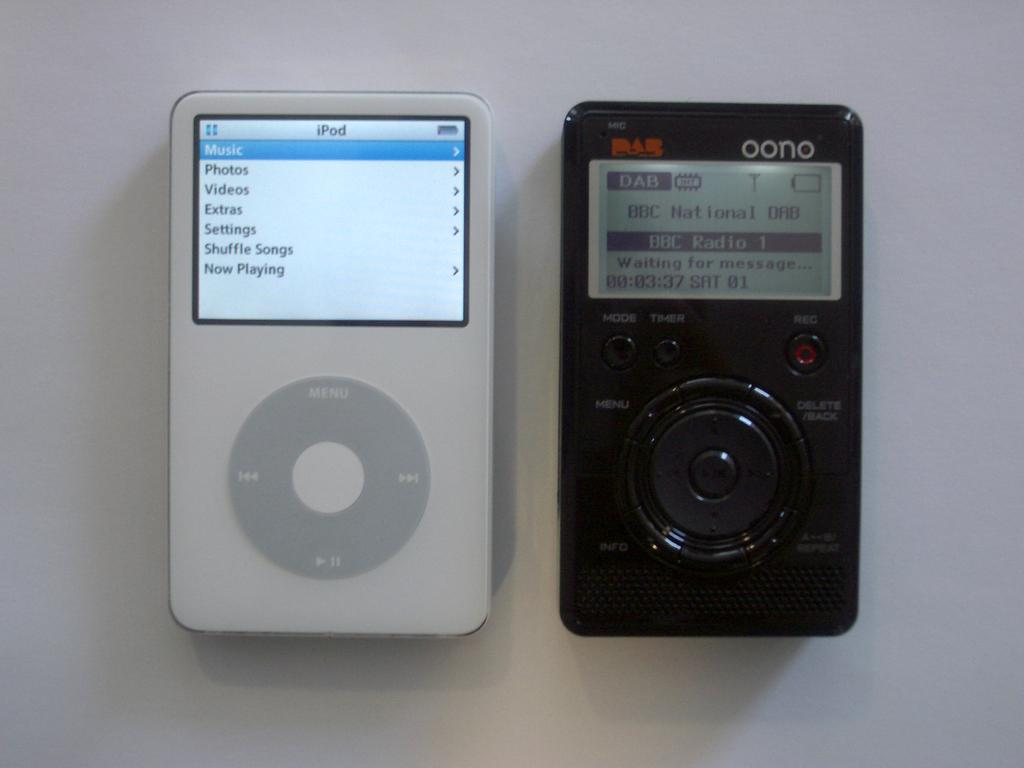What type of device is shown in the image? There are two airpods in the image. What colors are the airpods? The airpods are black and white in color. What surface are the airpods placed on? The airpods are on a white surface. What features can be seen on the airpods? The airpods have screens and buttons visible on them. What type of plot can be seen in the image? There is no plot visible in the image; it features two airpods on a white surface. Can you see a hole in the airpods in the image? There are no holes visible on the airpods in the image. 